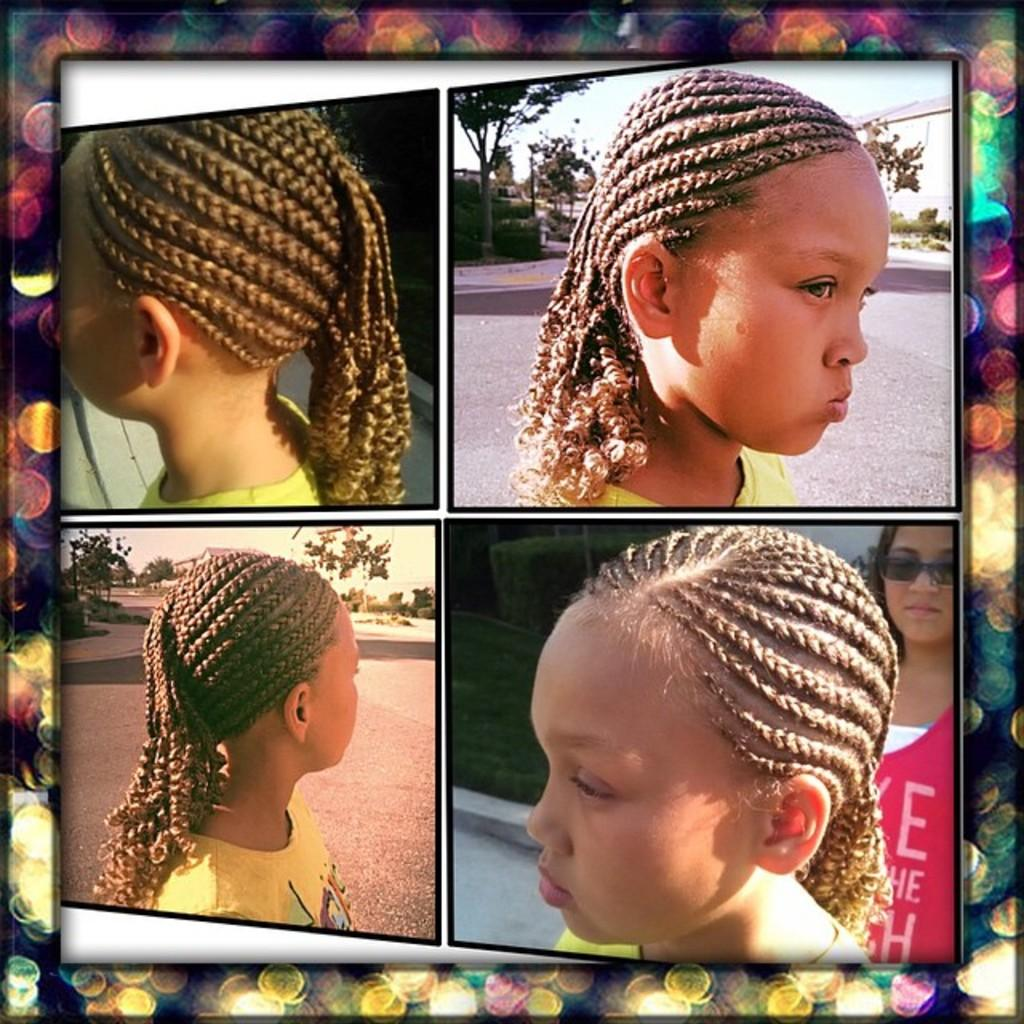What type of photos are present in the image? The image contains collage photos. How many girls are in the photos? There are two girls in the photos. What can be seen in the background of the photos? Trees and the sky are visible in the photos. What accessory is one of the girls wearing? One girl is wearing black shades. What type of noise can be heard coming from the stream in the image? There is no stream present in the image, so it is not possible to determine what type of noise might be heard. 